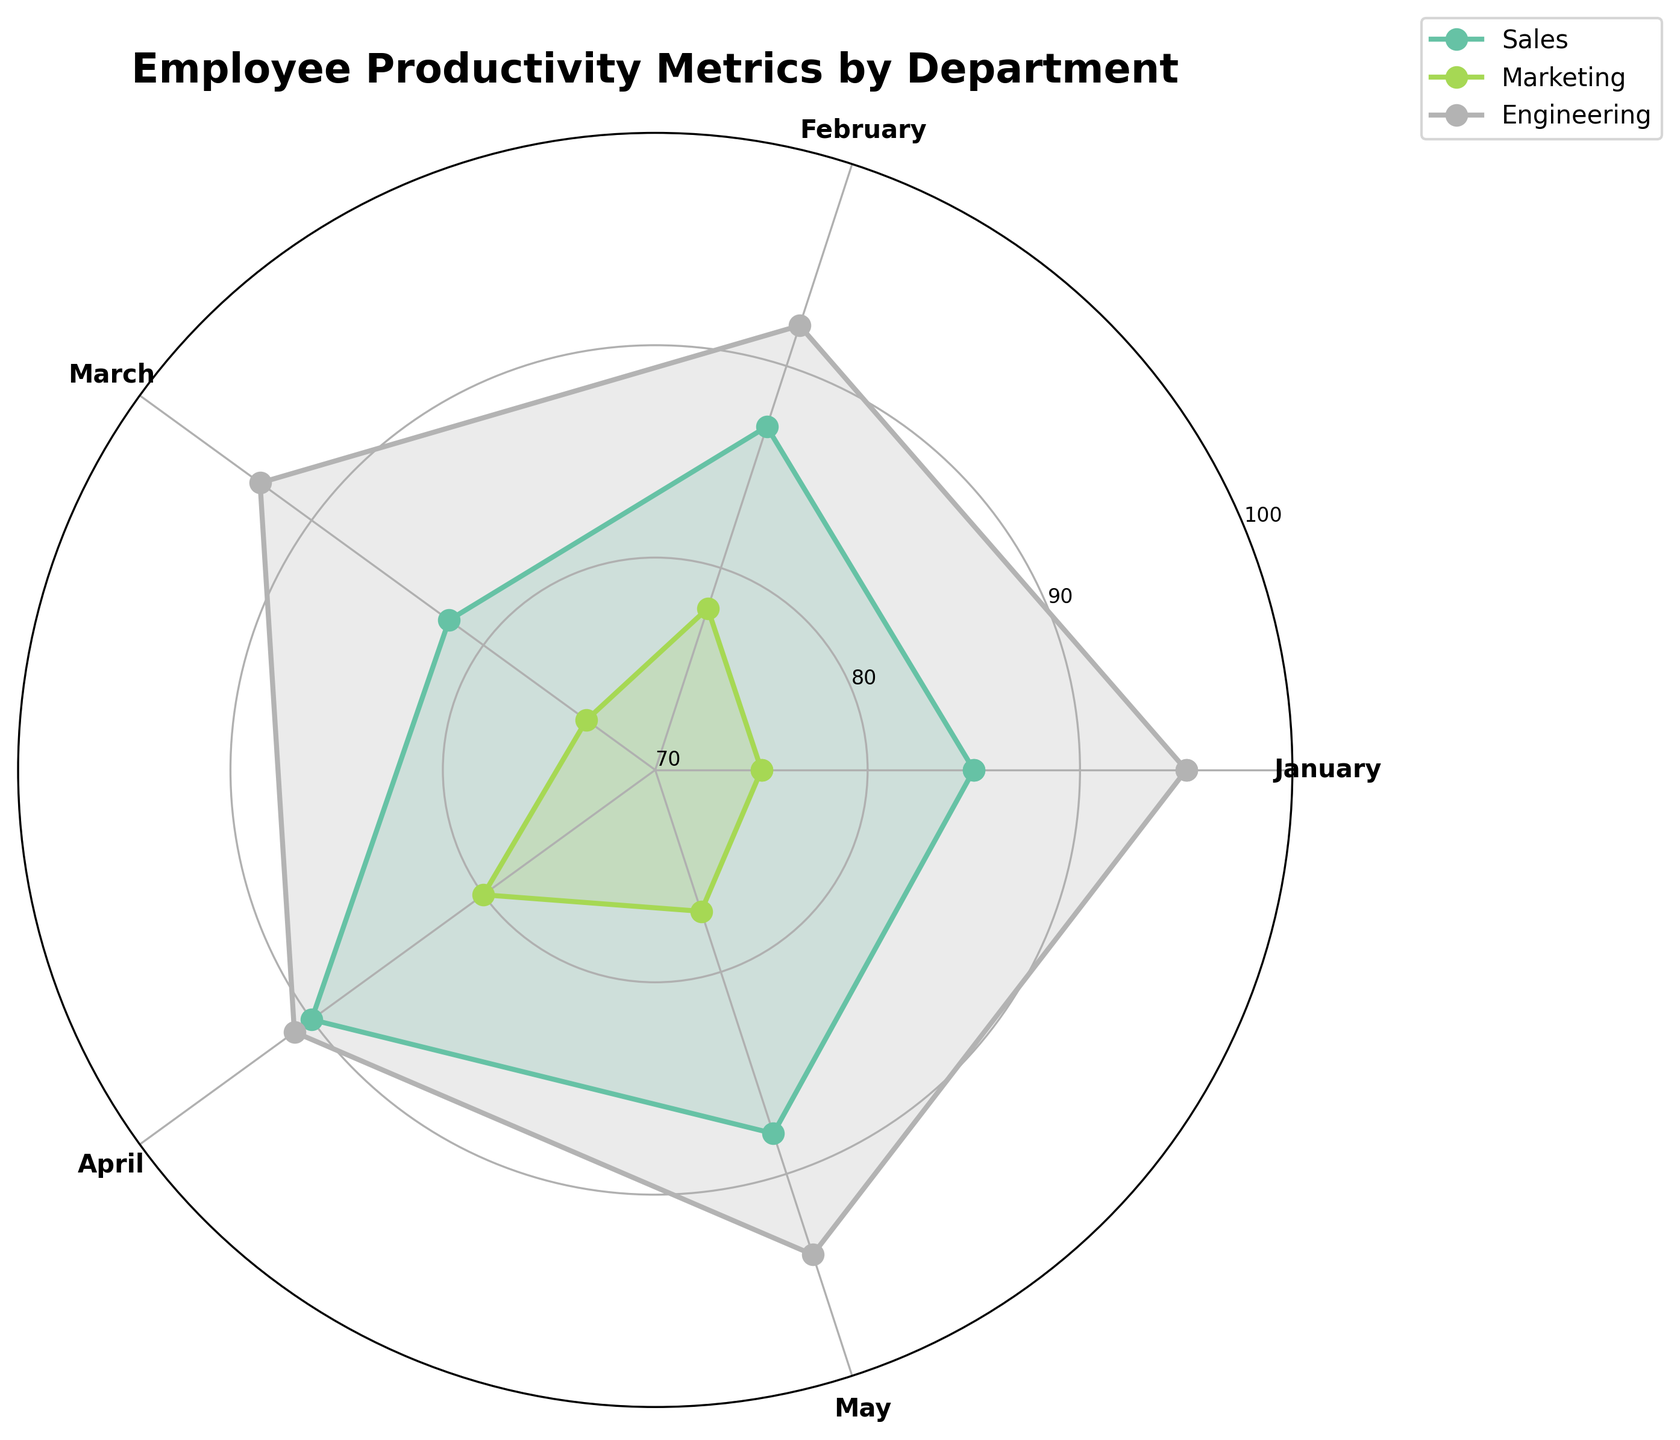What is the title of the figure? The title is located at the top of the figure. It summarizes the content displayed in the chart.
Answer: Employee Productivity Metrics by Department How many departments are compared in the chart? By counting the unique colors and labels on the chart's legend, we can determine the number of departments being compared.
Answer: 3 Which month has the highest productivity score for the Sales department? By following the Sales department line on the chart and identifying the highest point, we can determine the month that corresponds to this peak.
Answer: April What is the average productivity score for the Marketing department? Add all the productivity scores for the Marketing department and divide by the number of months to get the average. (75+78+74+80+77)/5 = 76.8
Answer: 76.8 Which department shows the most consistency in productivity scores across the months? By examining the spread of the lines representing each department, the department with the least fluctuation in productivity scores is the most consistent.
Answer: Engineering Compare the productivity scores of the Sales and Marketing departments in May. Which is higher? Look at the endpoints of the May labels for both Sales and Marketing departments and compare the values. Sales: 88, Marketing: 77.
Answer: Sales What is the difference in productivity scores between the highest and lowest departments in January? Identify the highest and lowest points for January across departments and subtract the lowest value from the highest. Engineering (95) - Marketing (75) = 20
Answer: 20 During which month did the Engineering department have the lowest productivity score? Trace the line representing the Engineering department and find the minimum value, then check the corresponding month.
Answer: April Which two departments have the closest productivity scores in March? Compare the values for each department in March and find the two departments whose values are closest. Sales: 82, Marketing: 74, Engineering: 93. Sales (82) and Marketing (74) have the difference of 8 which is the smallest.
Answer: Sales and Marketing What month saw the biggest drop in productivity for the Marketing department compared to the previous month? Calculate the difference in productivity scores month-to-month for the Marketing department and identify the largest drop. February (78) to March (74). Drop = 4.
Answer: March 